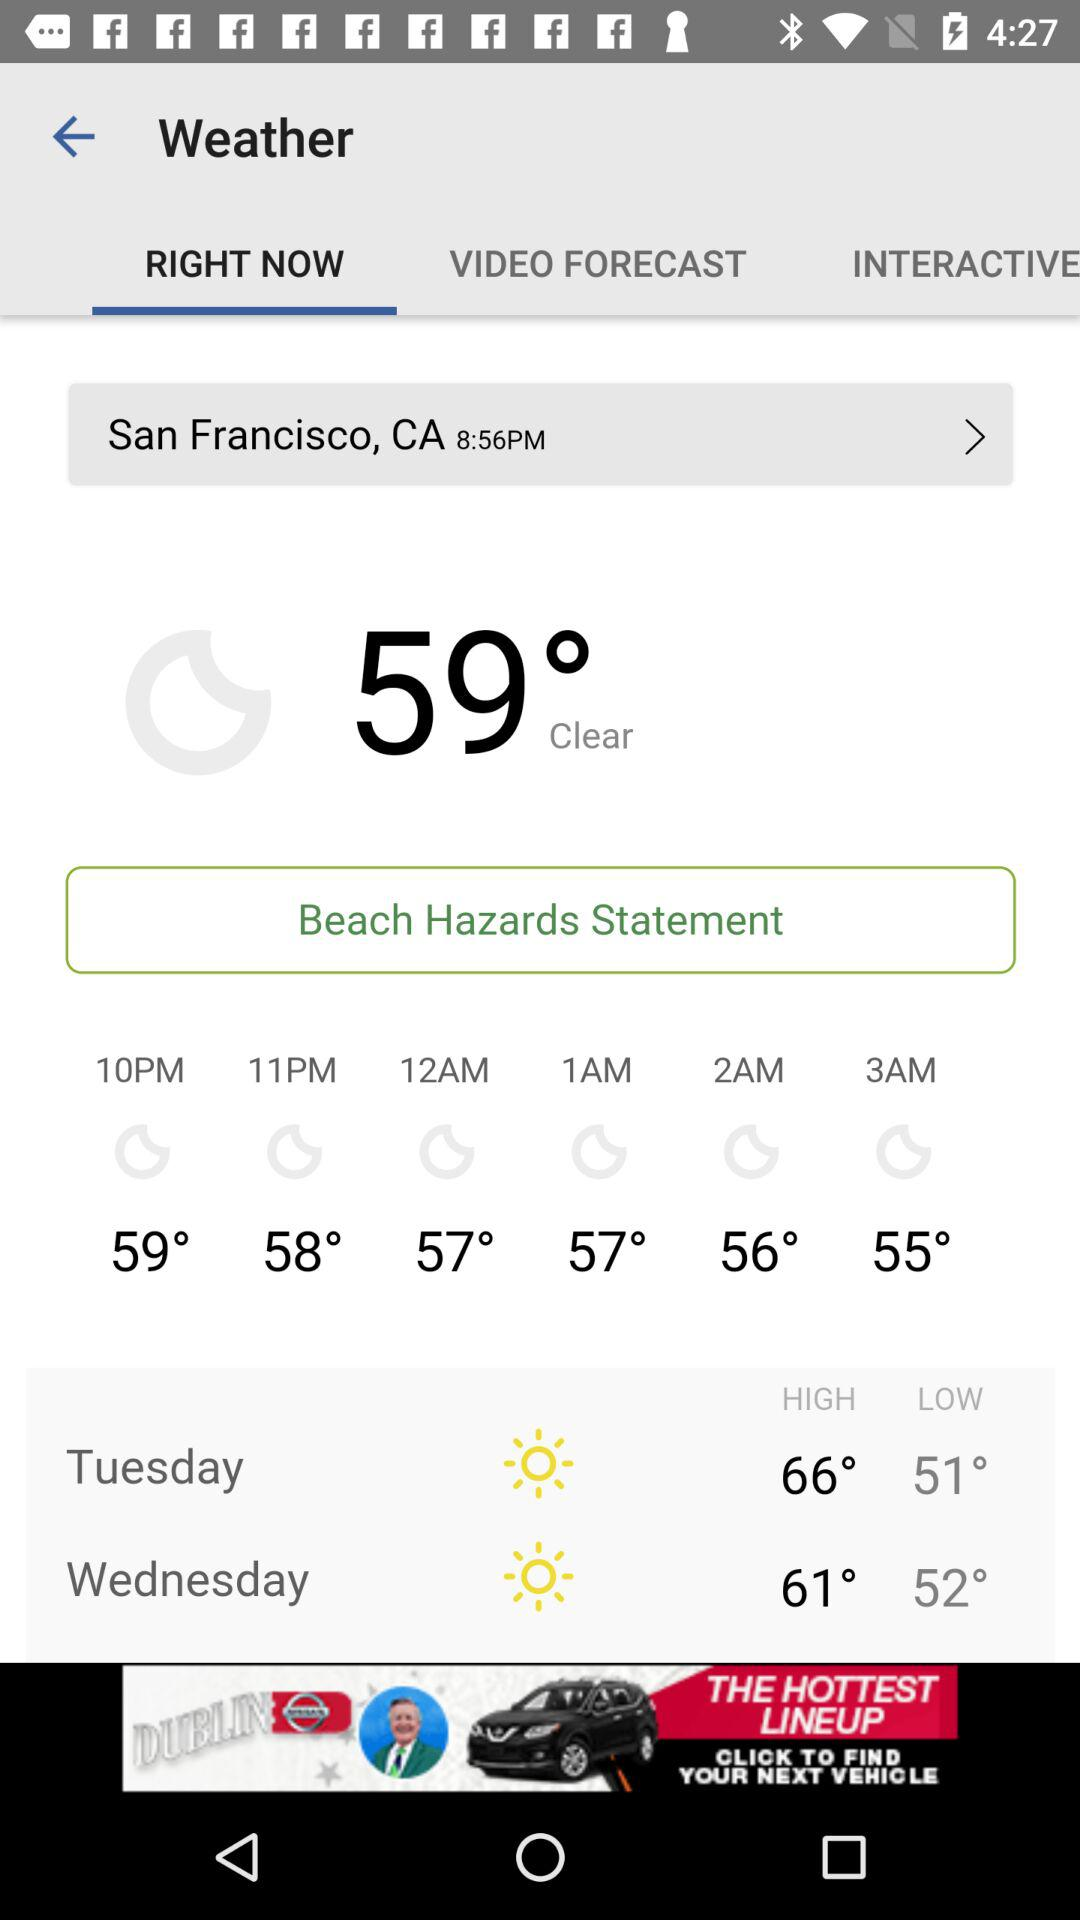How many degrees Fahrenheit is the difference between the high and low temperatures for Tuesday?
Answer the question using a single word or phrase. 15 